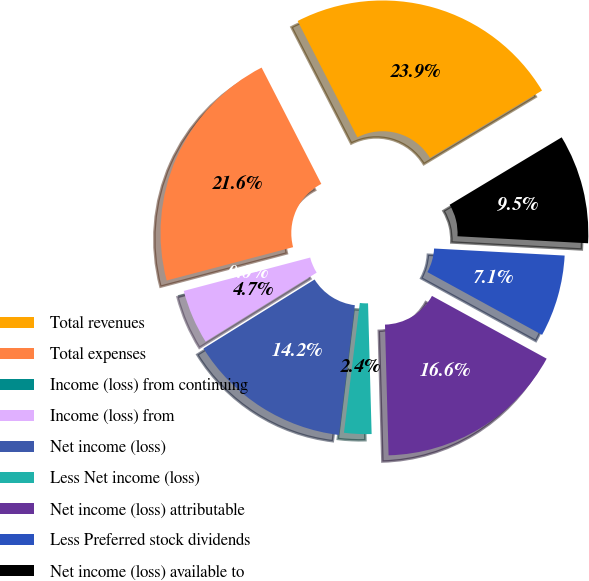Convert chart. <chart><loc_0><loc_0><loc_500><loc_500><pie_chart><fcel>Total revenues<fcel>Total expenses<fcel>Income (loss) from continuing<fcel>Income (loss) from<fcel>Net income (loss)<fcel>Less Net income (loss)<fcel>Net income (loss) attributable<fcel>Less Preferred stock dividends<fcel>Net income (loss) available to<nl><fcel>23.92%<fcel>21.55%<fcel>0.0%<fcel>4.74%<fcel>14.22%<fcel>2.37%<fcel>16.59%<fcel>7.11%<fcel>9.48%<nl></chart> 